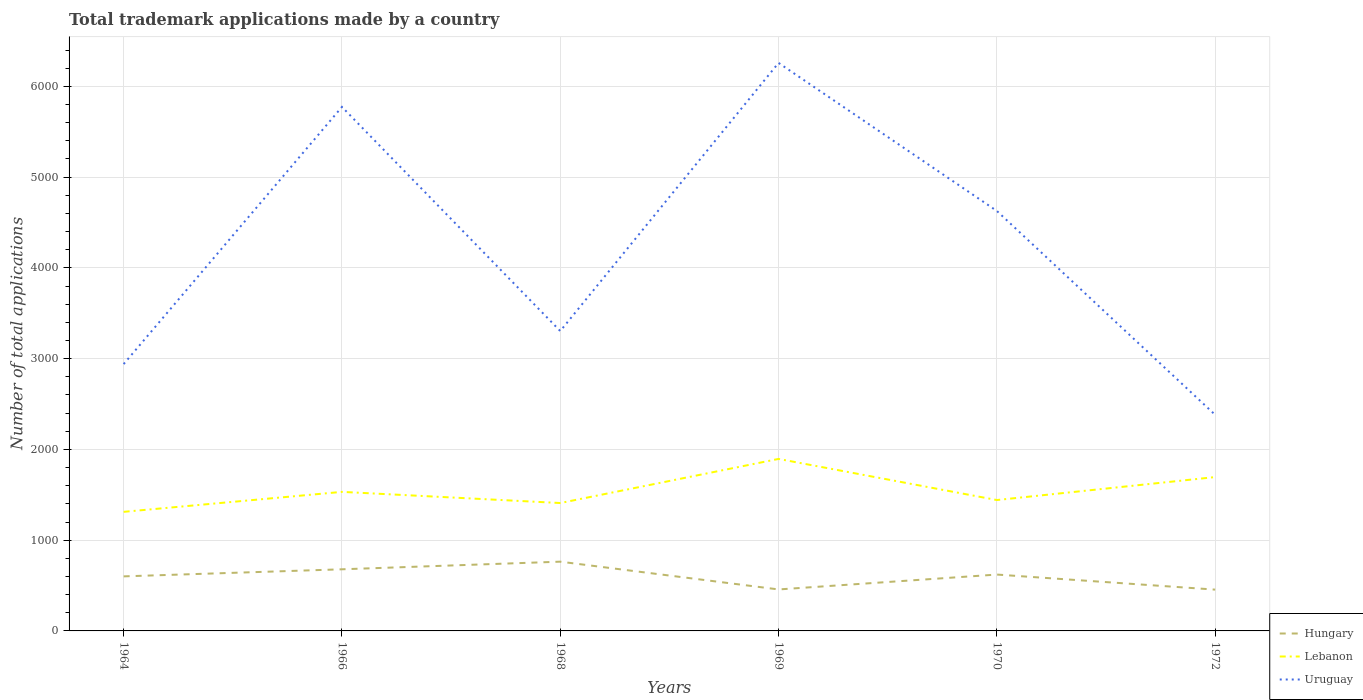Does the line corresponding to Hungary intersect with the line corresponding to Uruguay?
Your answer should be very brief. No. Across all years, what is the maximum number of applications made by in Hungary?
Offer a terse response. 455. What is the total number of applications made by in Uruguay in the graph?
Give a very brief answer. 923. What is the difference between the highest and the second highest number of applications made by in Uruguay?
Ensure brevity in your answer.  3877. What is the difference between the highest and the lowest number of applications made by in Uruguay?
Provide a succinct answer. 3. Is the number of applications made by in Lebanon strictly greater than the number of applications made by in Hungary over the years?
Ensure brevity in your answer.  No. How many lines are there?
Offer a terse response. 3. What is the difference between two consecutive major ticks on the Y-axis?
Give a very brief answer. 1000. Does the graph contain any zero values?
Your answer should be compact. No. Where does the legend appear in the graph?
Provide a succinct answer. Bottom right. How many legend labels are there?
Keep it short and to the point. 3. How are the legend labels stacked?
Ensure brevity in your answer.  Vertical. What is the title of the graph?
Make the answer very short. Total trademark applications made by a country. What is the label or title of the Y-axis?
Give a very brief answer. Number of total applications. What is the Number of total applications of Hungary in 1964?
Your response must be concise. 601. What is the Number of total applications in Lebanon in 1964?
Keep it short and to the point. 1312. What is the Number of total applications in Uruguay in 1964?
Provide a succinct answer. 2940. What is the Number of total applications of Hungary in 1966?
Ensure brevity in your answer.  679. What is the Number of total applications in Lebanon in 1966?
Your answer should be very brief. 1532. What is the Number of total applications in Uruguay in 1966?
Keep it short and to the point. 5773. What is the Number of total applications in Hungary in 1968?
Your answer should be very brief. 763. What is the Number of total applications of Lebanon in 1968?
Offer a terse response. 1409. What is the Number of total applications of Uruguay in 1968?
Make the answer very short. 3304. What is the Number of total applications of Hungary in 1969?
Your response must be concise. 457. What is the Number of total applications of Lebanon in 1969?
Keep it short and to the point. 1895. What is the Number of total applications of Uruguay in 1969?
Offer a terse response. 6258. What is the Number of total applications of Hungary in 1970?
Offer a very short reply. 621. What is the Number of total applications in Lebanon in 1970?
Offer a terse response. 1442. What is the Number of total applications of Uruguay in 1970?
Your answer should be very brief. 4627. What is the Number of total applications of Hungary in 1972?
Provide a succinct answer. 455. What is the Number of total applications of Lebanon in 1972?
Keep it short and to the point. 1695. What is the Number of total applications of Uruguay in 1972?
Offer a very short reply. 2381. Across all years, what is the maximum Number of total applications of Hungary?
Provide a short and direct response. 763. Across all years, what is the maximum Number of total applications in Lebanon?
Your answer should be compact. 1895. Across all years, what is the maximum Number of total applications of Uruguay?
Provide a short and direct response. 6258. Across all years, what is the minimum Number of total applications of Hungary?
Give a very brief answer. 455. Across all years, what is the minimum Number of total applications of Lebanon?
Your response must be concise. 1312. Across all years, what is the minimum Number of total applications of Uruguay?
Your answer should be very brief. 2381. What is the total Number of total applications in Hungary in the graph?
Give a very brief answer. 3576. What is the total Number of total applications of Lebanon in the graph?
Make the answer very short. 9285. What is the total Number of total applications in Uruguay in the graph?
Keep it short and to the point. 2.53e+04. What is the difference between the Number of total applications of Hungary in 1964 and that in 1966?
Your answer should be very brief. -78. What is the difference between the Number of total applications in Lebanon in 1964 and that in 1966?
Offer a terse response. -220. What is the difference between the Number of total applications of Uruguay in 1964 and that in 1966?
Ensure brevity in your answer.  -2833. What is the difference between the Number of total applications in Hungary in 1964 and that in 1968?
Your answer should be compact. -162. What is the difference between the Number of total applications in Lebanon in 1964 and that in 1968?
Give a very brief answer. -97. What is the difference between the Number of total applications in Uruguay in 1964 and that in 1968?
Your answer should be very brief. -364. What is the difference between the Number of total applications in Hungary in 1964 and that in 1969?
Make the answer very short. 144. What is the difference between the Number of total applications of Lebanon in 1964 and that in 1969?
Your response must be concise. -583. What is the difference between the Number of total applications of Uruguay in 1964 and that in 1969?
Offer a very short reply. -3318. What is the difference between the Number of total applications of Lebanon in 1964 and that in 1970?
Your answer should be very brief. -130. What is the difference between the Number of total applications of Uruguay in 1964 and that in 1970?
Keep it short and to the point. -1687. What is the difference between the Number of total applications of Hungary in 1964 and that in 1972?
Make the answer very short. 146. What is the difference between the Number of total applications of Lebanon in 1964 and that in 1972?
Provide a succinct answer. -383. What is the difference between the Number of total applications in Uruguay in 1964 and that in 1972?
Your answer should be very brief. 559. What is the difference between the Number of total applications in Hungary in 1966 and that in 1968?
Your response must be concise. -84. What is the difference between the Number of total applications in Lebanon in 1966 and that in 1968?
Provide a short and direct response. 123. What is the difference between the Number of total applications in Uruguay in 1966 and that in 1968?
Offer a terse response. 2469. What is the difference between the Number of total applications of Hungary in 1966 and that in 1969?
Offer a very short reply. 222. What is the difference between the Number of total applications of Lebanon in 1966 and that in 1969?
Your response must be concise. -363. What is the difference between the Number of total applications of Uruguay in 1966 and that in 1969?
Ensure brevity in your answer.  -485. What is the difference between the Number of total applications of Uruguay in 1966 and that in 1970?
Make the answer very short. 1146. What is the difference between the Number of total applications of Hungary in 1966 and that in 1972?
Your answer should be very brief. 224. What is the difference between the Number of total applications of Lebanon in 1966 and that in 1972?
Your response must be concise. -163. What is the difference between the Number of total applications of Uruguay in 1966 and that in 1972?
Offer a very short reply. 3392. What is the difference between the Number of total applications in Hungary in 1968 and that in 1969?
Your answer should be compact. 306. What is the difference between the Number of total applications of Lebanon in 1968 and that in 1969?
Give a very brief answer. -486. What is the difference between the Number of total applications in Uruguay in 1968 and that in 1969?
Make the answer very short. -2954. What is the difference between the Number of total applications of Hungary in 1968 and that in 1970?
Your response must be concise. 142. What is the difference between the Number of total applications in Lebanon in 1968 and that in 1970?
Keep it short and to the point. -33. What is the difference between the Number of total applications in Uruguay in 1968 and that in 1970?
Ensure brevity in your answer.  -1323. What is the difference between the Number of total applications in Hungary in 1968 and that in 1972?
Your answer should be very brief. 308. What is the difference between the Number of total applications of Lebanon in 1968 and that in 1972?
Provide a short and direct response. -286. What is the difference between the Number of total applications in Uruguay in 1968 and that in 1972?
Offer a very short reply. 923. What is the difference between the Number of total applications of Hungary in 1969 and that in 1970?
Your answer should be very brief. -164. What is the difference between the Number of total applications of Lebanon in 1969 and that in 1970?
Provide a short and direct response. 453. What is the difference between the Number of total applications of Uruguay in 1969 and that in 1970?
Your answer should be compact. 1631. What is the difference between the Number of total applications of Hungary in 1969 and that in 1972?
Your response must be concise. 2. What is the difference between the Number of total applications of Uruguay in 1969 and that in 1972?
Give a very brief answer. 3877. What is the difference between the Number of total applications in Hungary in 1970 and that in 1972?
Provide a short and direct response. 166. What is the difference between the Number of total applications of Lebanon in 1970 and that in 1972?
Your answer should be very brief. -253. What is the difference between the Number of total applications in Uruguay in 1970 and that in 1972?
Your answer should be very brief. 2246. What is the difference between the Number of total applications of Hungary in 1964 and the Number of total applications of Lebanon in 1966?
Ensure brevity in your answer.  -931. What is the difference between the Number of total applications of Hungary in 1964 and the Number of total applications of Uruguay in 1966?
Offer a terse response. -5172. What is the difference between the Number of total applications of Lebanon in 1964 and the Number of total applications of Uruguay in 1966?
Offer a very short reply. -4461. What is the difference between the Number of total applications in Hungary in 1964 and the Number of total applications in Lebanon in 1968?
Offer a very short reply. -808. What is the difference between the Number of total applications of Hungary in 1964 and the Number of total applications of Uruguay in 1968?
Ensure brevity in your answer.  -2703. What is the difference between the Number of total applications in Lebanon in 1964 and the Number of total applications in Uruguay in 1968?
Your response must be concise. -1992. What is the difference between the Number of total applications in Hungary in 1964 and the Number of total applications in Lebanon in 1969?
Offer a very short reply. -1294. What is the difference between the Number of total applications in Hungary in 1964 and the Number of total applications in Uruguay in 1969?
Give a very brief answer. -5657. What is the difference between the Number of total applications of Lebanon in 1964 and the Number of total applications of Uruguay in 1969?
Provide a succinct answer. -4946. What is the difference between the Number of total applications in Hungary in 1964 and the Number of total applications in Lebanon in 1970?
Your answer should be compact. -841. What is the difference between the Number of total applications of Hungary in 1964 and the Number of total applications of Uruguay in 1970?
Offer a terse response. -4026. What is the difference between the Number of total applications in Lebanon in 1964 and the Number of total applications in Uruguay in 1970?
Give a very brief answer. -3315. What is the difference between the Number of total applications in Hungary in 1964 and the Number of total applications in Lebanon in 1972?
Offer a very short reply. -1094. What is the difference between the Number of total applications of Hungary in 1964 and the Number of total applications of Uruguay in 1972?
Make the answer very short. -1780. What is the difference between the Number of total applications of Lebanon in 1964 and the Number of total applications of Uruguay in 1972?
Your response must be concise. -1069. What is the difference between the Number of total applications in Hungary in 1966 and the Number of total applications in Lebanon in 1968?
Your answer should be compact. -730. What is the difference between the Number of total applications in Hungary in 1966 and the Number of total applications in Uruguay in 1968?
Offer a very short reply. -2625. What is the difference between the Number of total applications in Lebanon in 1966 and the Number of total applications in Uruguay in 1968?
Your response must be concise. -1772. What is the difference between the Number of total applications of Hungary in 1966 and the Number of total applications of Lebanon in 1969?
Make the answer very short. -1216. What is the difference between the Number of total applications in Hungary in 1966 and the Number of total applications in Uruguay in 1969?
Provide a short and direct response. -5579. What is the difference between the Number of total applications of Lebanon in 1966 and the Number of total applications of Uruguay in 1969?
Your answer should be compact. -4726. What is the difference between the Number of total applications of Hungary in 1966 and the Number of total applications of Lebanon in 1970?
Your answer should be very brief. -763. What is the difference between the Number of total applications in Hungary in 1966 and the Number of total applications in Uruguay in 1970?
Provide a succinct answer. -3948. What is the difference between the Number of total applications in Lebanon in 1966 and the Number of total applications in Uruguay in 1970?
Keep it short and to the point. -3095. What is the difference between the Number of total applications in Hungary in 1966 and the Number of total applications in Lebanon in 1972?
Keep it short and to the point. -1016. What is the difference between the Number of total applications of Hungary in 1966 and the Number of total applications of Uruguay in 1972?
Your answer should be very brief. -1702. What is the difference between the Number of total applications of Lebanon in 1966 and the Number of total applications of Uruguay in 1972?
Make the answer very short. -849. What is the difference between the Number of total applications of Hungary in 1968 and the Number of total applications of Lebanon in 1969?
Your answer should be compact. -1132. What is the difference between the Number of total applications of Hungary in 1968 and the Number of total applications of Uruguay in 1969?
Your answer should be very brief. -5495. What is the difference between the Number of total applications in Lebanon in 1968 and the Number of total applications in Uruguay in 1969?
Provide a succinct answer. -4849. What is the difference between the Number of total applications in Hungary in 1968 and the Number of total applications in Lebanon in 1970?
Your answer should be compact. -679. What is the difference between the Number of total applications in Hungary in 1968 and the Number of total applications in Uruguay in 1970?
Offer a terse response. -3864. What is the difference between the Number of total applications in Lebanon in 1968 and the Number of total applications in Uruguay in 1970?
Your answer should be compact. -3218. What is the difference between the Number of total applications in Hungary in 1968 and the Number of total applications in Lebanon in 1972?
Offer a terse response. -932. What is the difference between the Number of total applications in Hungary in 1968 and the Number of total applications in Uruguay in 1972?
Give a very brief answer. -1618. What is the difference between the Number of total applications of Lebanon in 1968 and the Number of total applications of Uruguay in 1972?
Offer a terse response. -972. What is the difference between the Number of total applications in Hungary in 1969 and the Number of total applications in Lebanon in 1970?
Keep it short and to the point. -985. What is the difference between the Number of total applications in Hungary in 1969 and the Number of total applications in Uruguay in 1970?
Give a very brief answer. -4170. What is the difference between the Number of total applications in Lebanon in 1969 and the Number of total applications in Uruguay in 1970?
Provide a short and direct response. -2732. What is the difference between the Number of total applications in Hungary in 1969 and the Number of total applications in Lebanon in 1972?
Your response must be concise. -1238. What is the difference between the Number of total applications of Hungary in 1969 and the Number of total applications of Uruguay in 1972?
Provide a succinct answer. -1924. What is the difference between the Number of total applications in Lebanon in 1969 and the Number of total applications in Uruguay in 1972?
Give a very brief answer. -486. What is the difference between the Number of total applications of Hungary in 1970 and the Number of total applications of Lebanon in 1972?
Provide a succinct answer. -1074. What is the difference between the Number of total applications of Hungary in 1970 and the Number of total applications of Uruguay in 1972?
Offer a very short reply. -1760. What is the difference between the Number of total applications in Lebanon in 1970 and the Number of total applications in Uruguay in 1972?
Offer a terse response. -939. What is the average Number of total applications of Hungary per year?
Offer a very short reply. 596. What is the average Number of total applications of Lebanon per year?
Give a very brief answer. 1547.5. What is the average Number of total applications of Uruguay per year?
Give a very brief answer. 4213.83. In the year 1964, what is the difference between the Number of total applications of Hungary and Number of total applications of Lebanon?
Provide a succinct answer. -711. In the year 1964, what is the difference between the Number of total applications of Hungary and Number of total applications of Uruguay?
Provide a succinct answer. -2339. In the year 1964, what is the difference between the Number of total applications of Lebanon and Number of total applications of Uruguay?
Offer a terse response. -1628. In the year 1966, what is the difference between the Number of total applications of Hungary and Number of total applications of Lebanon?
Your answer should be compact. -853. In the year 1966, what is the difference between the Number of total applications in Hungary and Number of total applications in Uruguay?
Offer a terse response. -5094. In the year 1966, what is the difference between the Number of total applications of Lebanon and Number of total applications of Uruguay?
Make the answer very short. -4241. In the year 1968, what is the difference between the Number of total applications in Hungary and Number of total applications in Lebanon?
Offer a terse response. -646. In the year 1968, what is the difference between the Number of total applications of Hungary and Number of total applications of Uruguay?
Keep it short and to the point. -2541. In the year 1968, what is the difference between the Number of total applications in Lebanon and Number of total applications in Uruguay?
Ensure brevity in your answer.  -1895. In the year 1969, what is the difference between the Number of total applications of Hungary and Number of total applications of Lebanon?
Your answer should be very brief. -1438. In the year 1969, what is the difference between the Number of total applications in Hungary and Number of total applications in Uruguay?
Give a very brief answer. -5801. In the year 1969, what is the difference between the Number of total applications in Lebanon and Number of total applications in Uruguay?
Your response must be concise. -4363. In the year 1970, what is the difference between the Number of total applications of Hungary and Number of total applications of Lebanon?
Give a very brief answer. -821. In the year 1970, what is the difference between the Number of total applications of Hungary and Number of total applications of Uruguay?
Your answer should be very brief. -4006. In the year 1970, what is the difference between the Number of total applications in Lebanon and Number of total applications in Uruguay?
Your answer should be compact. -3185. In the year 1972, what is the difference between the Number of total applications in Hungary and Number of total applications in Lebanon?
Provide a short and direct response. -1240. In the year 1972, what is the difference between the Number of total applications in Hungary and Number of total applications in Uruguay?
Ensure brevity in your answer.  -1926. In the year 1972, what is the difference between the Number of total applications in Lebanon and Number of total applications in Uruguay?
Your response must be concise. -686. What is the ratio of the Number of total applications of Hungary in 1964 to that in 1966?
Provide a succinct answer. 0.89. What is the ratio of the Number of total applications of Lebanon in 1964 to that in 1966?
Offer a very short reply. 0.86. What is the ratio of the Number of total applications of Uruguay in 1964 to that in 1966?
Your answer should be very brief. 0.51. What is the ratio of the Number of total applications in Hungary in 1964 to that in 1968?
Give a very brief answer. 0.79. What is the ratio of the Number of total applications of Lebanon in 1964 to that in 1968?
Provide a short and direct response. 0.93. What is the ratio of the Number of total applications in Uruguay in 1964 to that in 1968?
Offer a terse response. 0.89. What is the ratio of the Number of total applications of Hungary in 1964 to that in 1969?
Offer a terse response. 1.32. What is the ratio of the Number of total applications of Lebanon in 1964 to that in 1969?
Make the answer very short. 0.69. What is the ratio of the Number of total applications in Uruguay in 1964 to that in 1969?
Your answer should be very brief. 0.47. What is the ratio of the Number of total applications of Hungary in 1964 to that in 1970?
Your response must be concise. 0.97. What is the ratio of the Number of total applications of Lebanon in 1964 to that in 1970?
Ensure brevity in your answer.  0.91. What is the ratio of the Number of total applications of Uruguay in 1964 to that in 1970?
Your answer should be very brief. 0.64. What is the ratio of the Number of total applications in Hungary in 1964 to that in 1972?
Provide a short and direct response. 1.32. What is the ratio of the Number of total applications of Lebanon in 1964 to that in 1972?
Give a very brief answer. 0.77. What is the ratio of the Number of total applications in Uruguay in 1964 to that in 1972?
Keep it short and to the point. 1.23. What is the ratio of the Number of total applications of Hungary in 1966 to that in 1968?
Give a very brief answer. 0.89. What is the ratio of the Number of total applications in Lebanon in 1966 to that in 1968?
Keep it short and to the point. 1.09. What is the ratio of the Number of total applications in Uruguay in 1966 to that in 1968?
Provide a succinct answer. 1.75. What is the ratio of the Number of total applications of Hungary in 1966 to that in 1969?
Give a very brief answer. 1.49. What is the ratio of the Number of total applications of Lebanon in 1966 to that in 1969?
Make the answer very short. 0.81. What is the ratio of the Number of total applications of Uruguay in 1966 to that in 1969?
Provide a succinct answer. 0.92. What is the ratio of the Number of total applications in Hungary in 1966 to that in 1970?
Your answer should be very brief. 1.09. What is the ratio of the Number of total applications of Lebanon in 1966 to that in 1970?
Offer a terse response. 1.06. What is the ratio of the Number of total applications in Uruguay in 1966 to that in 1970?
Your answer should be compact. 1.25. What is the ratio of the Number of total applications in Hungary in 1966 to that in 1972?
Give a very brief answer. 1.49. What is the ratio of the Number of total applications of Lebanon in 1966 to that in 1972?
Give a very brief answer. 0.9. What is the ratio of the Number of total applications in Uruguay in 1966 to that in 1972?
Your answer should be very brief. 2.42. What is the ratio of the Number of total applications of Hungary in 1968 to that in 1969?
Keep it short and to the point. 1.67. What is the ratio of the Number of total applications in Lebanon in 1968 to that in 1969?
Your response must be concise. 0.74. What is the ratio of the Number of total applications in Uruguay in 1968 to that in 1969?
Keep it short and to the point. 0.53. What is the ratio of the Number of total applications in Hungary in 1968 to that in 1970?
Your answer should be compact. 1.23. What is the ratio of the Number of total applications of Lebanon in 1968 to that in 1970?
Offer a terse response. 0.98. What is the ratio of the Number of total applications in Uruguay in 1968 to that in 1970?
Ensure brevity in your answer.  0.71. What is the ratio of the Number of total applications of Hungary in 1968 to that in 1972?
Your answer should be compact. 1.68. What is the ratio of the Number of total applications in Lebanon in 1968 to that in 1972?
Make the answer very short. 0.83. What is the ratio of the Number of total applications of Uruguay in 1968 to that in 1972?
Make the answer very short. 1.39. What is the ratio of the Number of total applications in Hungary in 1969 to that in 1970?
Make the answer very short. 0.74. What is the ratio of the Number of total applications of Lebanon in 1969 to that in 1970?
Offer a very short reply. 1.31. What is the ratio of the Number of total applications of Uruguay in 1969 to that in 1970?
Keep it short and to the point. 1.35. What is the ratio of the Number of total applications in Lebanon in 1969 to that in 1972?
Offer a terse response. 1.12. What is the ratio of the Number of total applications of Uruguay in 1969 to that in 1972?
Provide a succinct answer. 2.63. What is the ratio of the Number of total applications in Hungary in 1970 to that in 1972?
Offer a terse response. 1.36. What is the ratio of the Number of total applications of Lebanon in 1970 to that in 1972?
Your answer should be compact. 0.85. What is the ratio of the Number of total applications in Uruguay in 1970 to that in 1972?
Provide a succinct answer. 1.94. What is the difference between the highest and the second highest Number of total applications of Hungary?
Offer a terse response. 84. What is the difference between the highest and the second highest Number of total applications of Uruguay?
Make the answer very short. 485. What is the difference between the highest and the lowest Number of total applications in Hungary?
Ensure brevity in your answer.  308. What is the difference between the highest and the lowest Number of total applications of Lebanon?
Offer a very short reply. 583. What is the difference between the highest and the lowest Number of total applications in Uruguay?
Keep it short and to the point. 3877. 